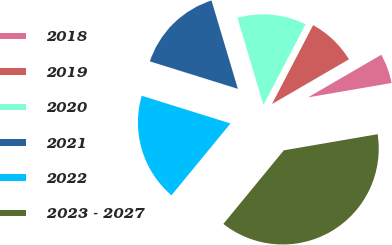<chart> <loc_0><loc_0><loc_500><loc_500><pie_chart><fcel>2018<fcel>2019<fcel>2020<fcel>2021<fcel>2022<fcel>2023 - 2027<nl><fcel>5.67%<fcel>8.97%<fcel>12.27%<fcel>15.57%<fcel>18.87%<fcel>38.66%<nl></chart> 